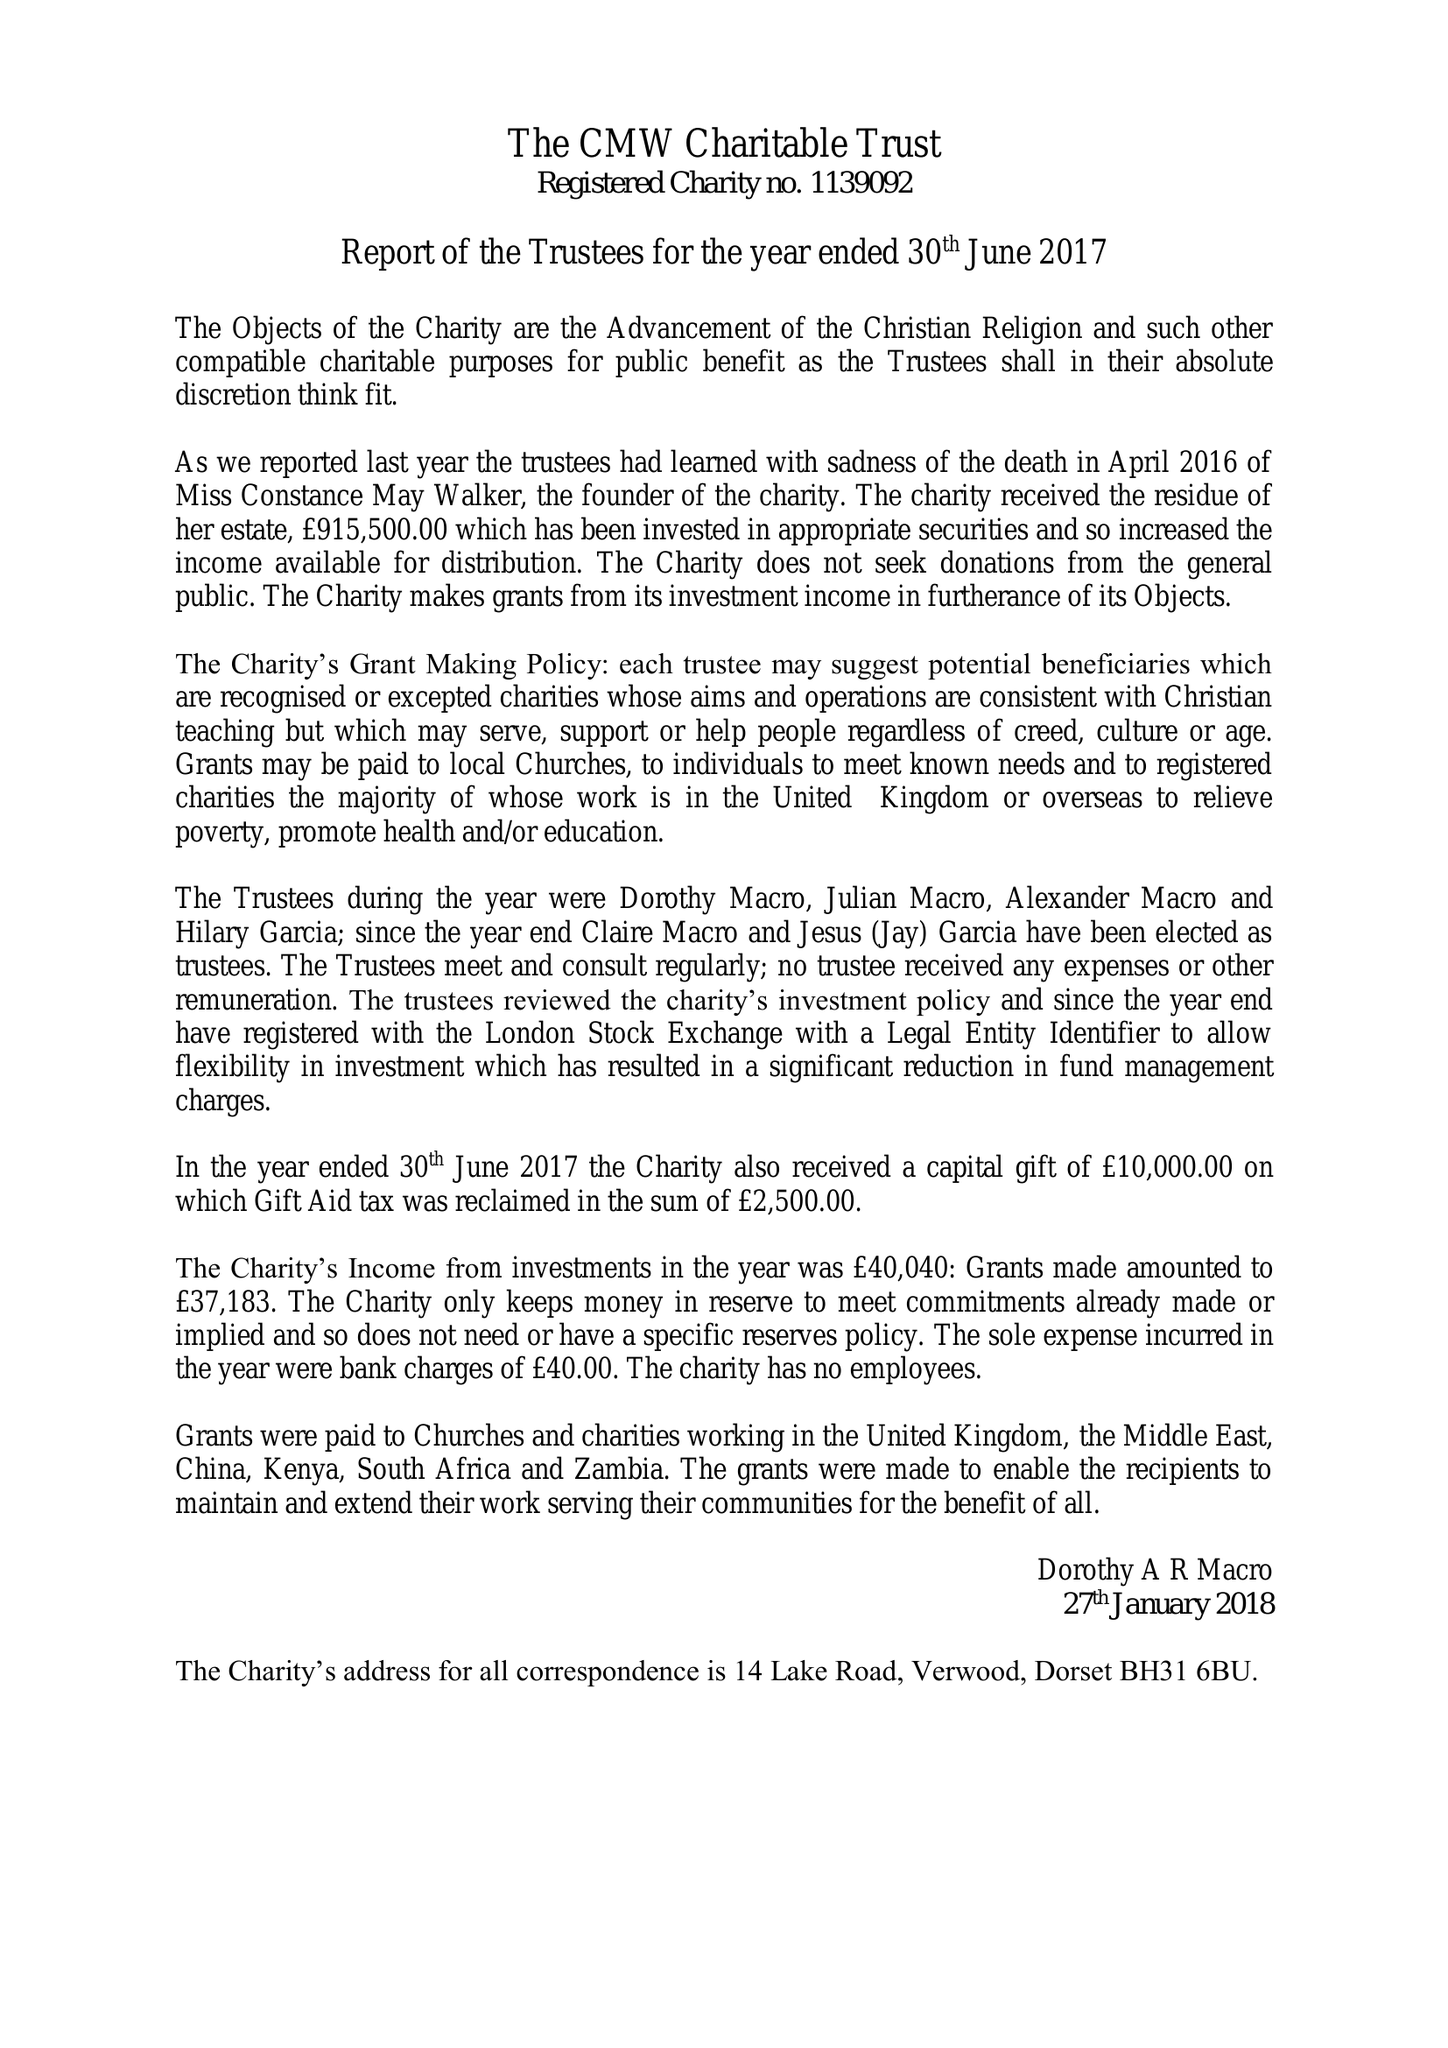What is the value for the income_annually_in_british_pounds?
Answer the question using a single word or phrase. 40040.00 